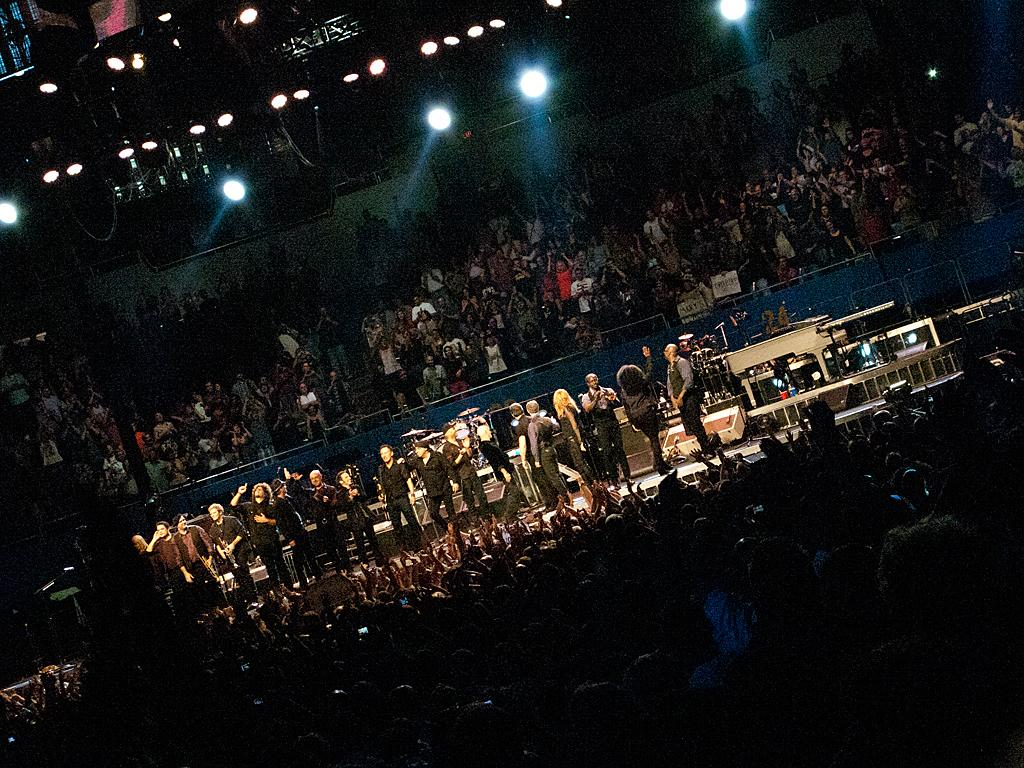What is the main subject of the image? The main subject of the image is a crowd. What else can be seen in the image besides the crowd? There are musical instruments and focusing lights in the image. How many bananas are being played as musical instruments in the image? There are no bananas present in the image, let alone being used as musical instruments. 